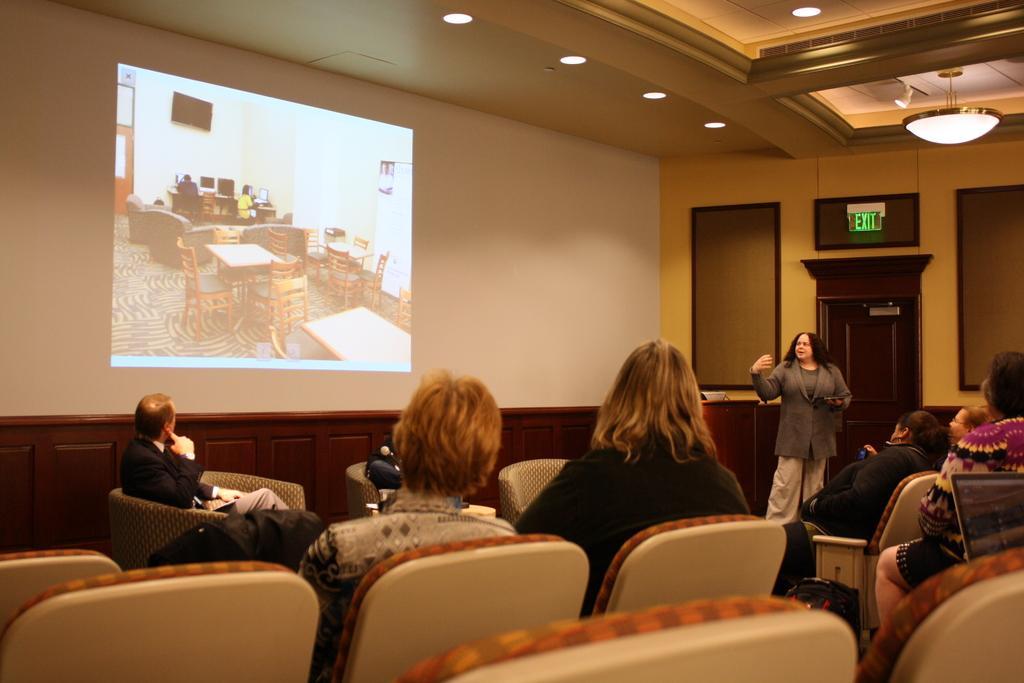In one or two sentences, can you explain what this image depicts? As we can see in the image there is a screen, light and few people sitting on chairs. 